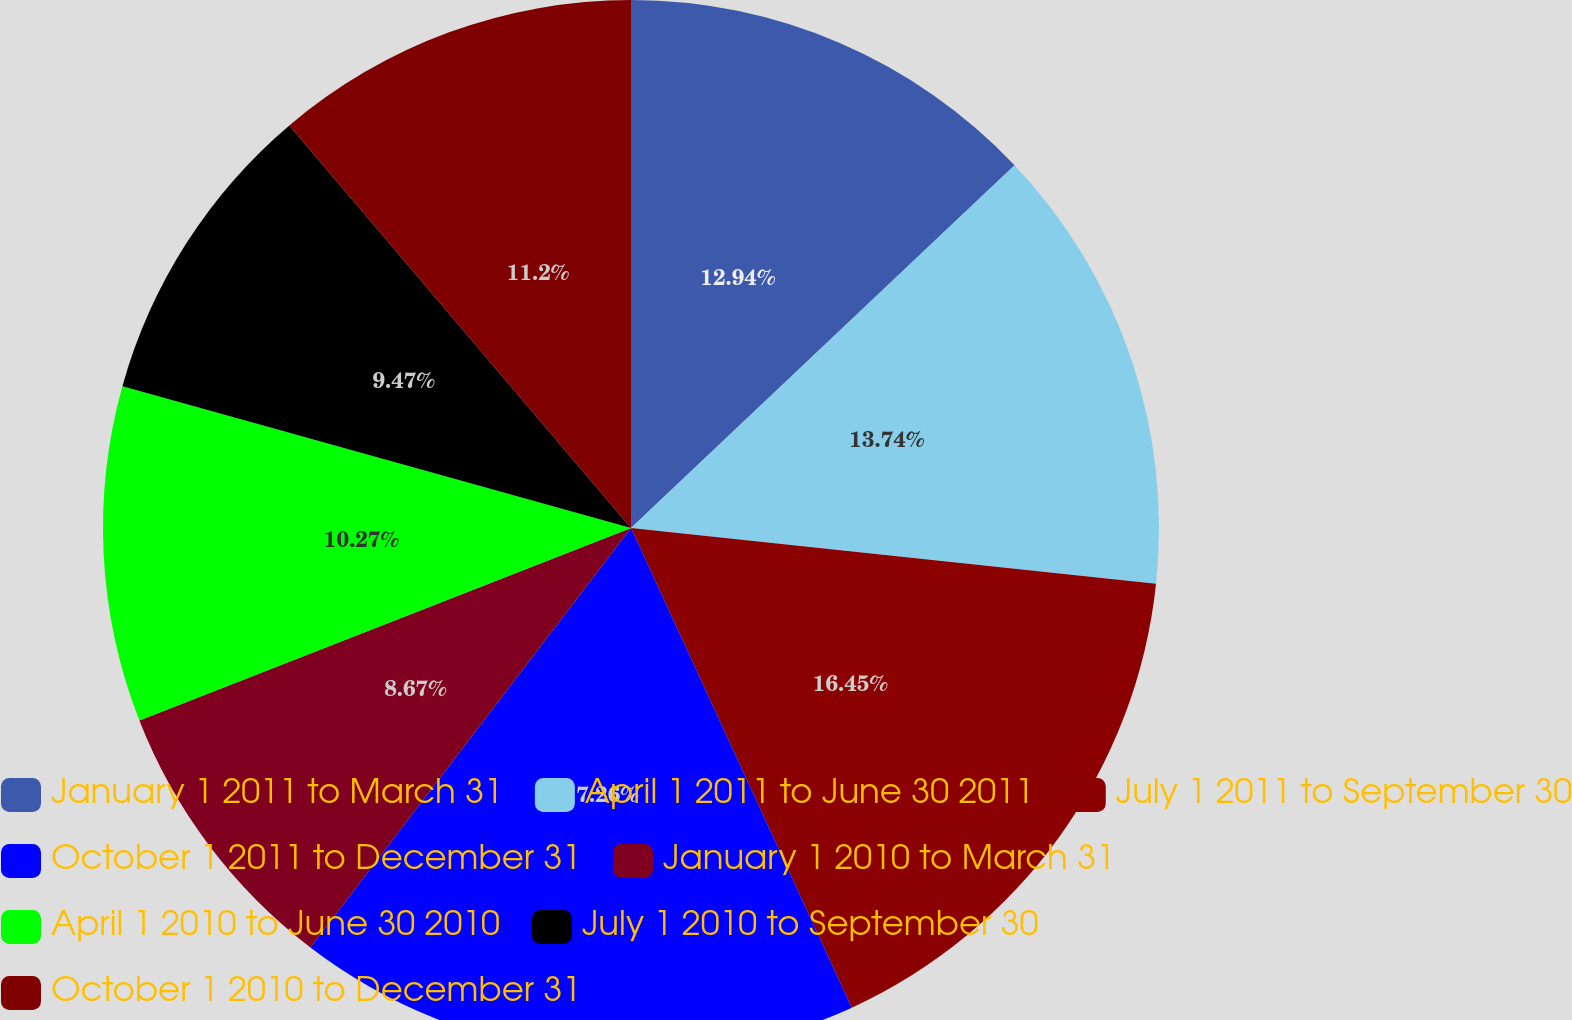Convert chart to OTSL. <chart><loc_0><loc_0><loc_500><loc_500><pie_chart><fcel>January 1 2011 to March 31<fcel>April 1 2011 to June 30 2011<fcel>July 1 2011 to September 30<fcel>October 1 2011 to December 31<fcel>January 1 2010 to March 31<fcel>April 1 2010 to June 30 2010<fcel>July 1 2010 to September 30<fcel>October 1 2010 to December 31<nl><fcel>12.94%<fcel>13.74%<fcel>16.45%<fcel>17.25%<fcel>8.67%<fcel>10.27%<fcel>9.47%<fcel>11.2%<nl></chart> 